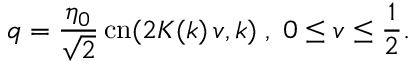<formula> <loc_0><loc_0><loc_500><loc_500>q = { \frac { \eta _ { 0 } } { \sqrt { 2 } } } \, c n ( 2 K ( k ) \, v , k ) \, , \, 0 \leq v \leq \frac { 1 } { 2 } .</formula> 